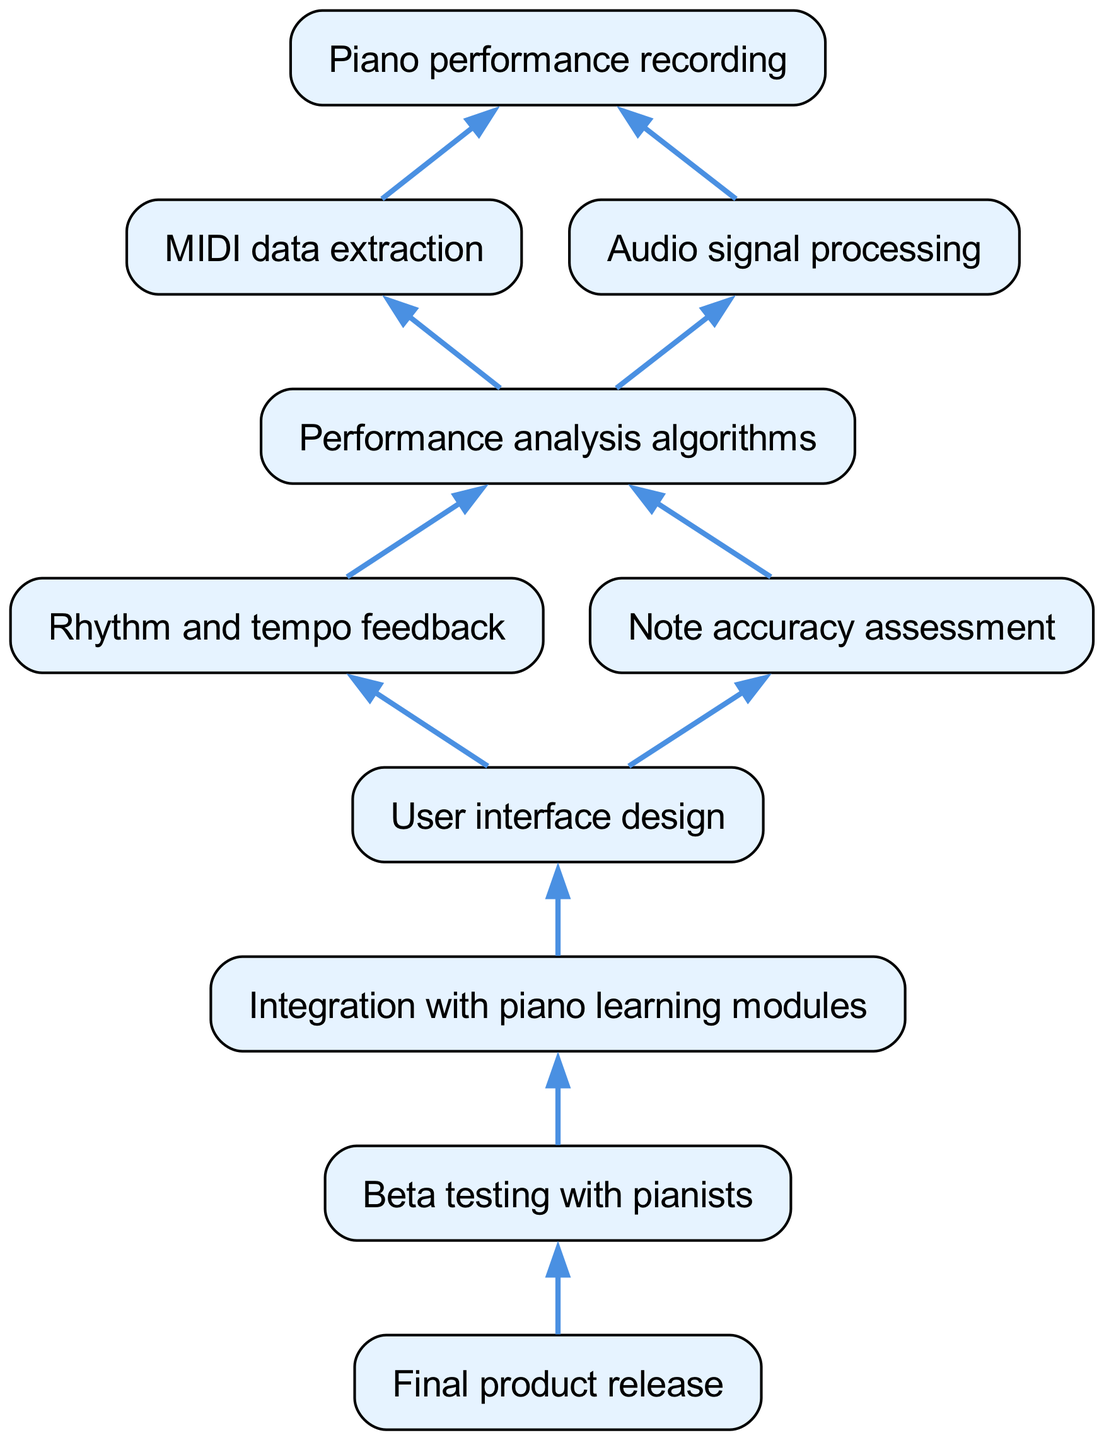What is the starting point of the flow chart? The starting point of the flow chart is identified as "Piano performance recording," which has two children nodes stemming from it.
Answer: Piano performance recording How many children does "Performance analysis algorithms" have? "Performance analysis algorithms" has two children, which are "Rhythm and tempo feedback" and "Note accuracy assessment." This is evident from the flow chart structure where the nodes branch out from "Performance analysis algorithms."
Answer: 2 Which node leads to "User interface design"? The node that leads to "User interface design" is "Performance analysis algorithms." Following the flow upward, "Performance analysis algorithms" is connected to "User interface design" as the next step in the process.
Answer: Performance analysis algorithms What is the final step in the development stages? The final step in the development stages is represented by the node "Final product release," which signifies the conclusion of the workflow within the chart.
Answer: Final product release What type of feedback does "Rhythm and tempo feedback" provide? "Rhythm and tempo feedback" provides feedback related to the performance aspects that help pianists improve their timing and rhythm during practice sessions, as indicated by its position in the flow chart.
Answer: Feedback Which components are integrated with the user interface? The components integrated with the user interface are "Integration with piano learning modules," as shown by its direct connection to "User interface design" in the flow chart.
Answer: Integration with piano learning modules What is the order of stages leading to beta testing? The order leading to beta testing starts at "Piano performance recording," then proceeds to "Performance analysis algorithms," followed by "User interface design," concluding at "Beta testing with pianists." Thus it showcases a clear sequence leading up to testing.
Answer: Piano performance recording, Performance analysis algorithms, User interface design, Beta testing with pianists 